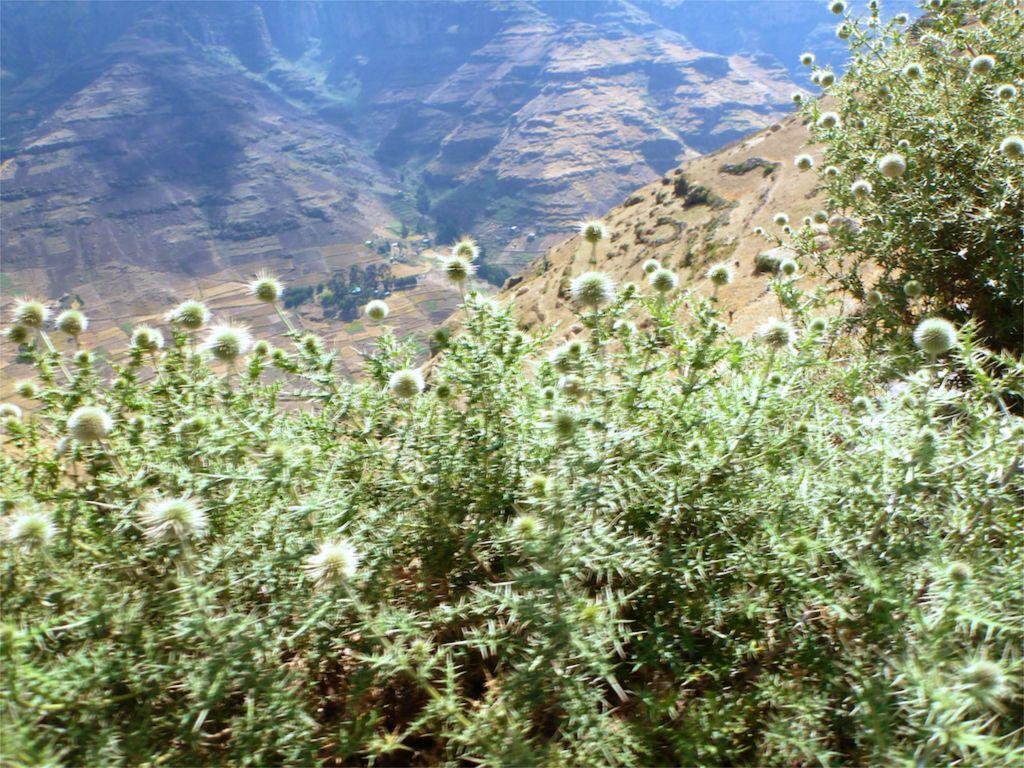How would you summarize this image in a sentence or two? In this image we can see the plants with flowers and mountains. 